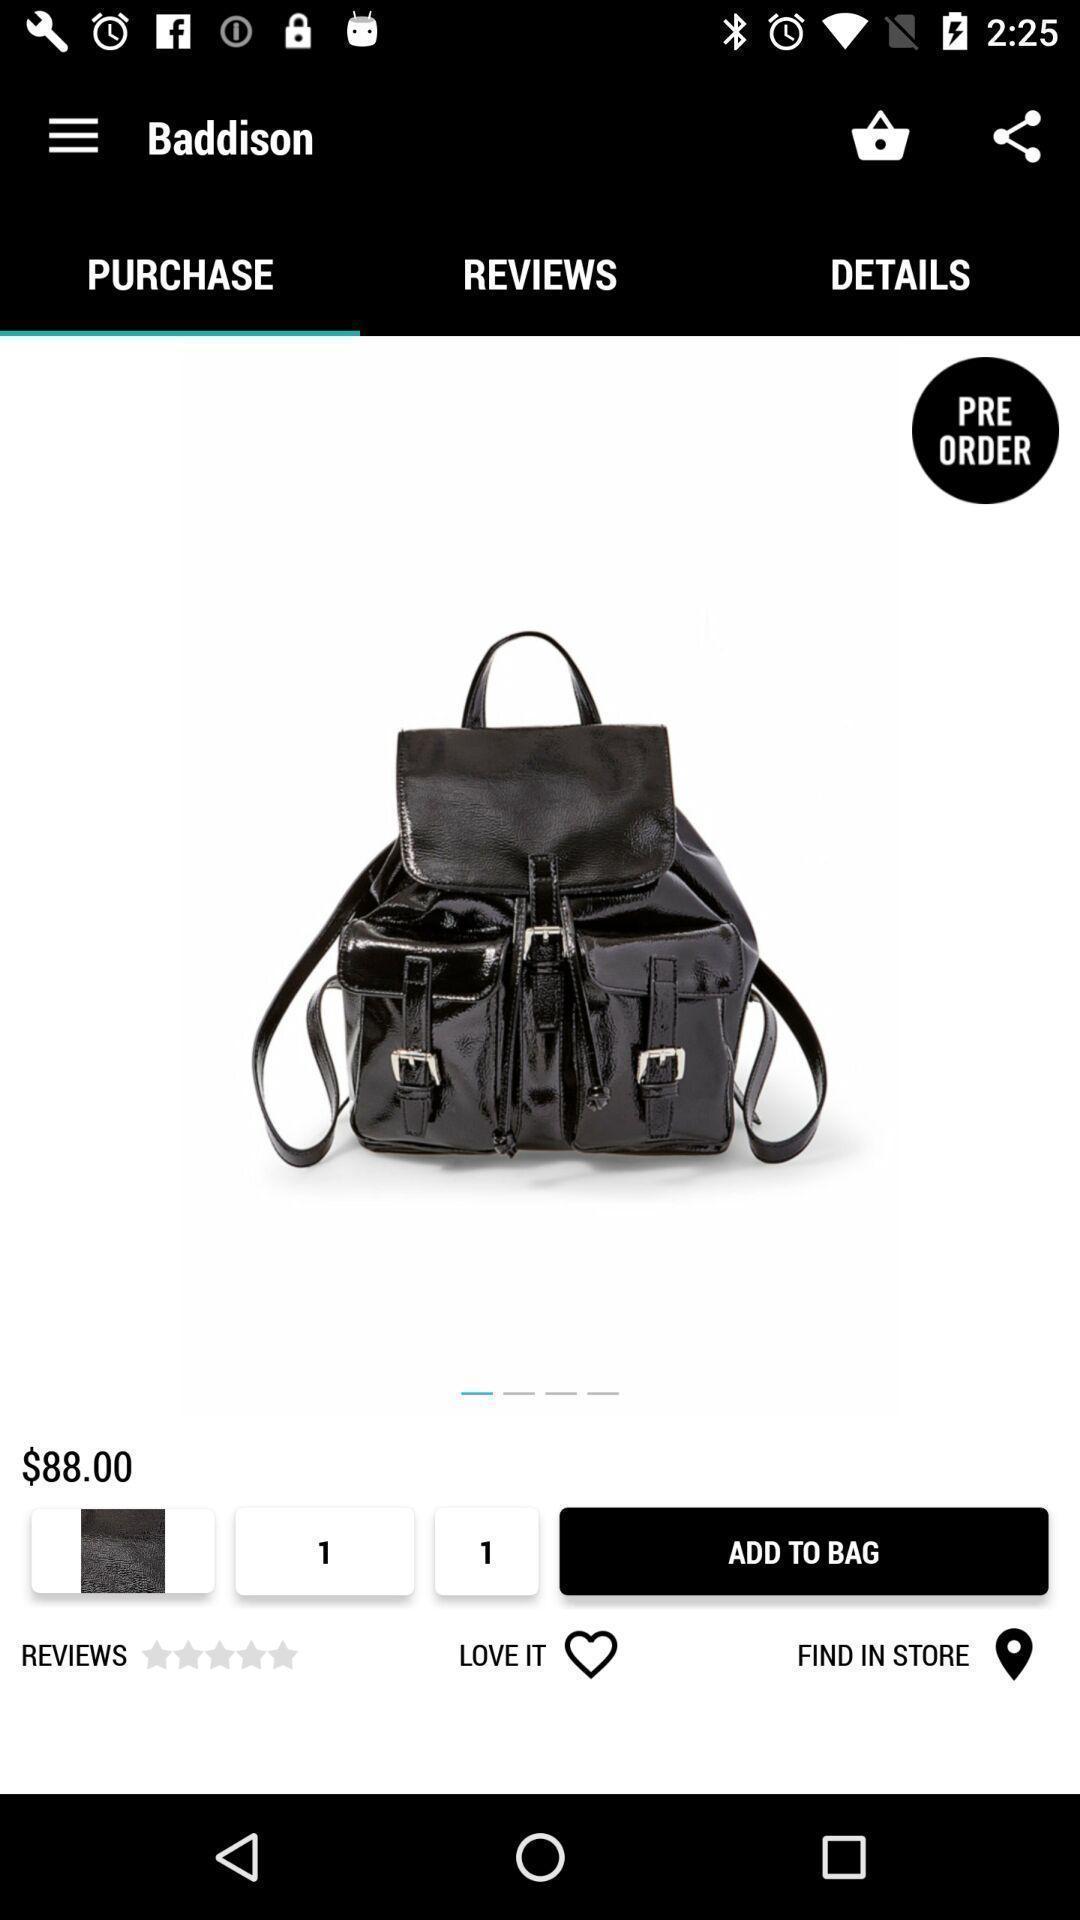Explain the elements present in this screenshot. Page showing information about product in shopping app. 